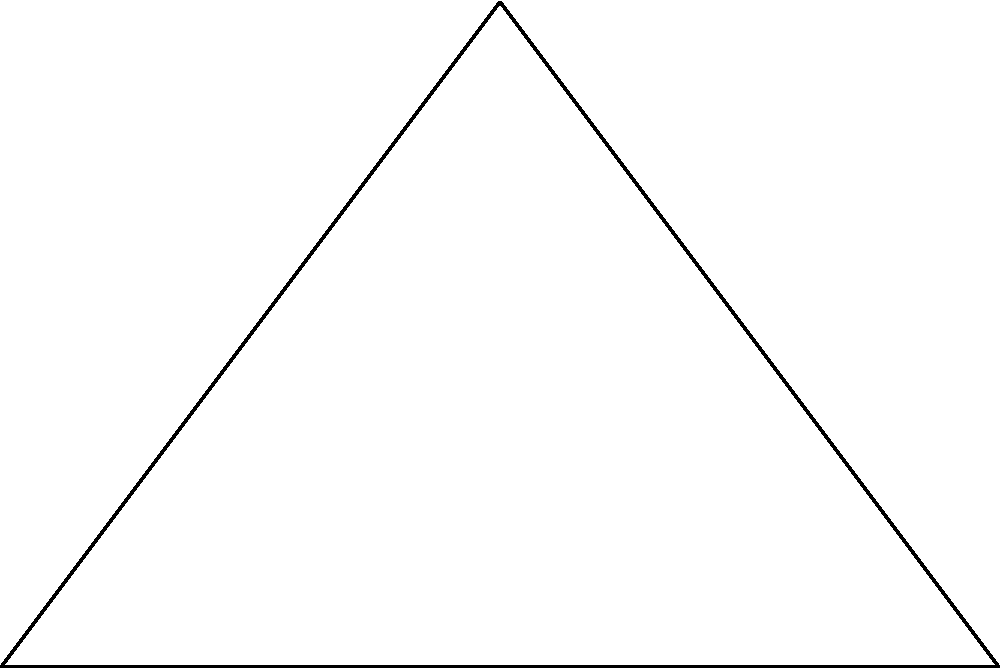A triangular garden plot on the Noble's Hospital premises has a base of 6 meters and a height of 4 meters. What is the area of this garden plot in square meters? To find the area of a triangular garden plot, we can use the formula for the area of a triangle:

$$ \text{Area} = \frac{1}{2} \times \text{base} \times \text{height} $$

Given:
- Base = 6 meters
- Height = 4 meters

Let's substitute these values into the formula:

$$ \text{Area} = \frac{1}{2} \times 6 \text{ m} \times 4 \text{ m} $$

Now, let's calculate:

$$ \text{Area} = \frac{1}{2} \times 24 \text{ m}^2 = 12 \text{ m}^2 $$

Therefore, the area of the triangular garden plot is 12 square meters.
Answer: $12 \text{ m}^2$ 